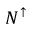Convert formula to latex. <formula><loc_0><loc_0><loc_500><loc_500>N ^ { \uparrow }</formula> 